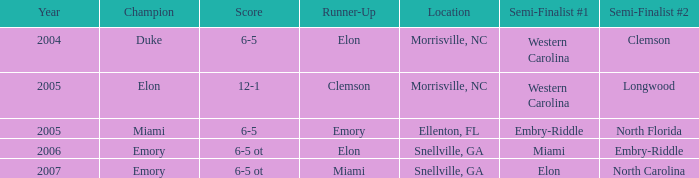Can you give me this table as a dict? {'header': ['Year', 'Champion', 'Score', 'Runner-Up', 'Location', 'Semi-Finalist #1', 'Semi-Finalist #2'], 'rows': [['2004', 'Duke', '6-5', 'Elon', 'Morrisville, NC', 'Western Carolina', 'Clemson'], ['2005', 'Elon', '12-1', 'Clemson', 'Morrisville, NC', 'Western Carolina', 'Longwood'], ['2005', 'Miami', '6-5', 'Emory', 'Ellenton, FL', 'Embry-Riddle', 'North Florida'], ['2006', 'Emory', '6-5 ot', 'Elon', 'Snellville, GA', 'Miami', 'Embry-Riddle'], ['2007', 'Emory', '6-5 ot', 'Miami', 'Snellville, GA', 'Elon', 'North Carolina']]} List the scores of all games when Miami were listed as the first Semi finalist 6-5 ot. 